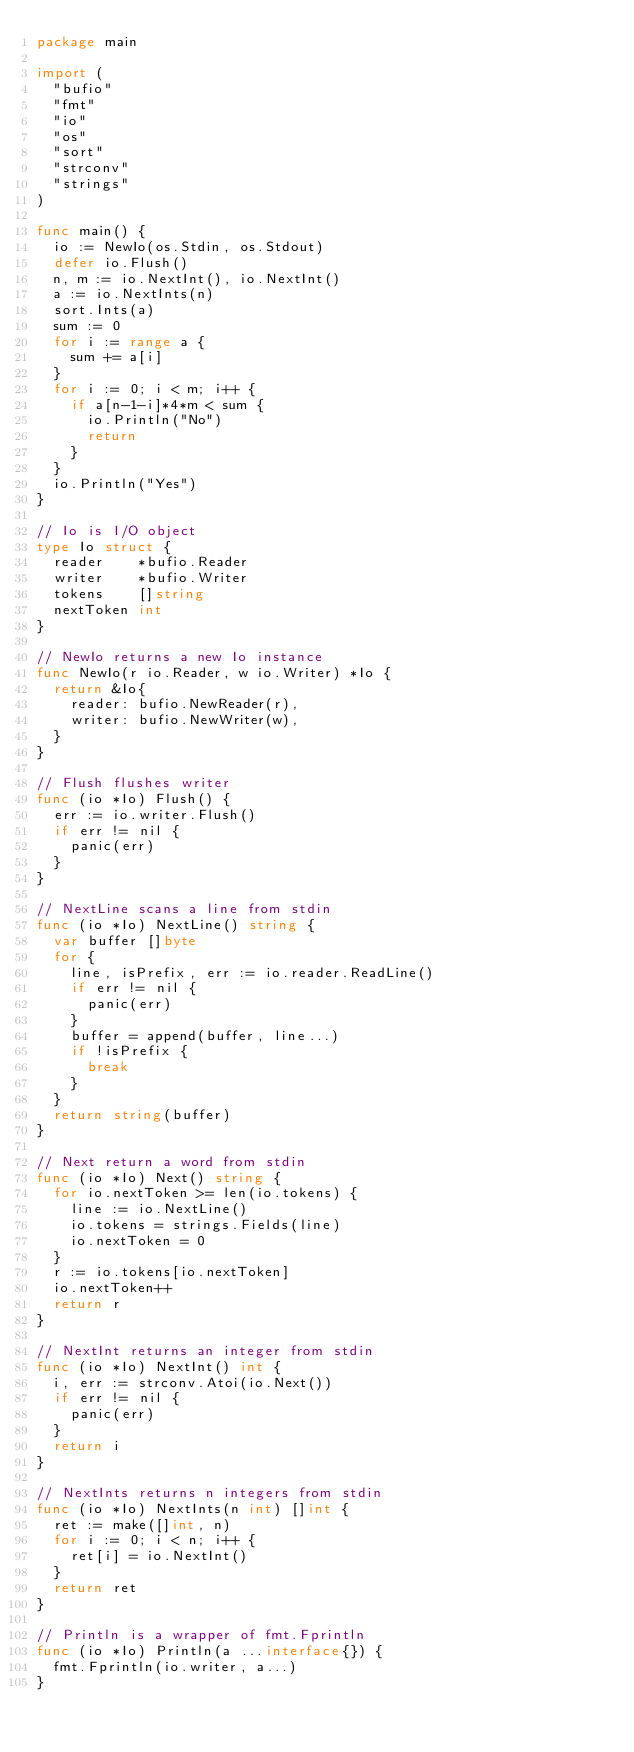<code> <loc_0><loc_0><loc_500><loc_500><_Go_>package main

import (
	"bufio"
	"fmt"
	"io"
	"os"
	"sort"
	"strconv"
	"strings"
)

func main() {
	io := NewIo(os.Stdin, os.Stdout)
	defer io.Flush()
	n, m := io.NextInt(), io.NextInt()
	a := io.NextInts(n)
	sort.Ints(a)
	sum := 0
	for i := range a {
		sum += a[i]
	}
	for i := 0; i < m; i++ {
		if a[n-1-i]*4*m < sum {
			io.Println("No")
			return
		}
	}
	io.Println("Yes")
}

// Io is I/O object
type Io struct {
	reader    *bufio.Reader
	writer    *bufio.Writer
	tokens    []string
	nextToken int
}

// NewIo returns a new Io instance
func NewIo(r io.Reader, w io.Writer) *Io {
	return &Io{
		reader: bufio.NewReader(r),
		writer: bufio.NewWriter(w),
	}
}

// Flush flushes writer
func (io *Io) Flush() {
	err := io.writer.Flush()
	if err != nil {
		panic(err)
	}
}

// NextLine scans a line from stdin
func (io *Io) NextLine() string {
	var buffer []byte
	for {
		line, isPrefix, err := io.reader.ReadLine()
		if err != nil {
			panic(err)
		}
		buffer = append(buffer, line...)
		if !isPrefix {
			break
		}
	}
	return string(buffer)
}

// Next return a word from stdin
func (io *Io) Next() string {
	for io.nextToken >= len(io.tokens) {
		line := io.NextLine()
		io.tokens = strings.Fields(line)
		io.nextToken = 0
	}
	r := io.tokens[io.nextToken]
	io.nextToken++
	return r
}

// NextInt returns an integer from stdin
func (io *Io) NextInt() int {
	i, err := strconv.Atoi(io.Next())
	if err != nil {
		panic(err)
	}
	return i
}

// NextInts returns n integers from stdin
func (io *Io) NextInts(n int) []int {
	ret := make([]int, n)
	for i := 0; i < n; i++ {
		ret[i] = io.NextInt()
	}
	return ret
}

// Println is a wrapper of fmt.Fprintln
func (io *Io) Println(a ...interface{}) {
	fmt.Fprintln(io.writer, a...)
}
</code> 